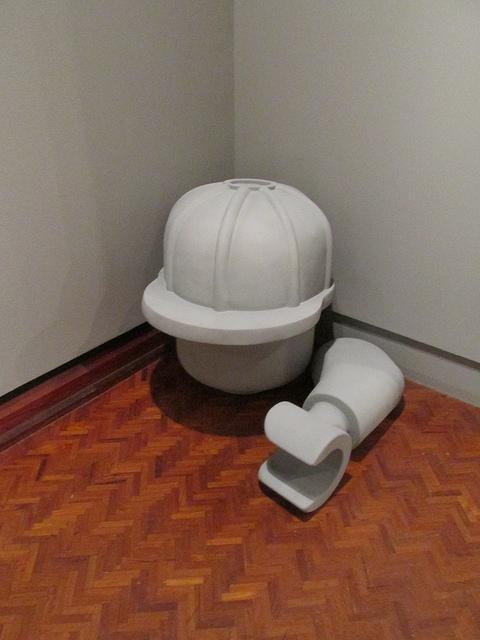What color is the floor?
Give a very brief answer. Brown. What is on the floor?
Be succinct. Lego. How many items are on the wall?
Keep it brief. 0. 